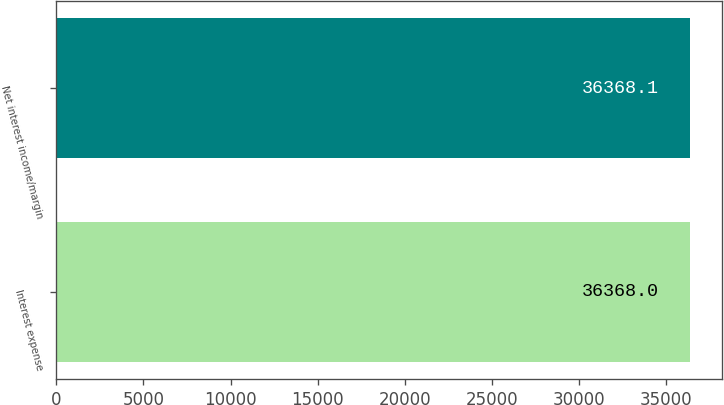Convert chart to OTSL. <chart><loc_0><loc_0><loc_500><loc_500><bar_chart><fcel>Interest expense<fcel>Net interest income/margin<nl><fcel>36368<fcel>36368.1<nl></chart> 